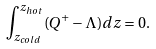Convert formula to latex. <formula><loc_0><loc_0><loc_500><loc_500>\int _ { z _ { c o l d } } ^ { z _ { h o t } } ( Q ^ { + } - \Lambda ) d z = 0 .</formula> 